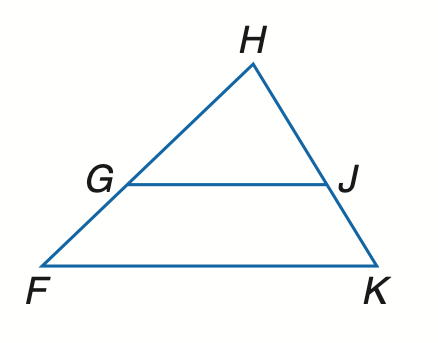Answer the mathemtical geometry problem and directly provide the correct option letter.
Question: Find x so that G J \parallel F K. G F = 12, H G = 6, H J = 8, J K = x - 4.
Choices: A: 12 B: 16 C: 18 D: 20 D 